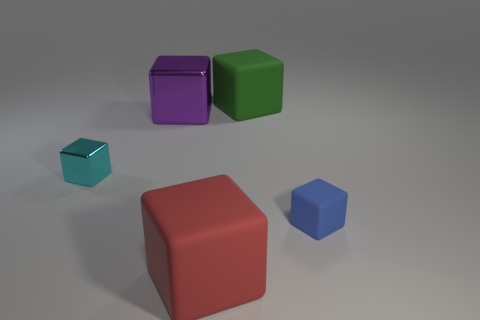Subtract 1 cubes. How many cubes are left? 4 Subtract all red blocks. How many blocks are left? 4 Subtract all cyan cubes. How many cubes are left? 4 Subtract all gray cubes. Subtract all gray cylinders. How many cubes are left? 5 Add 3 big matte objects. How many objects exist? 8 Subtract 0 yellow cylinders. How many objects are left? 5 Subtract all big blue matte blocks. Subtract all matte things. How many objects are left? 2 Add 1 shiny blocks. How many shiny blocks are left? 3 Add 2 tiny purple balls. How many tiny purple balls exist? 2 